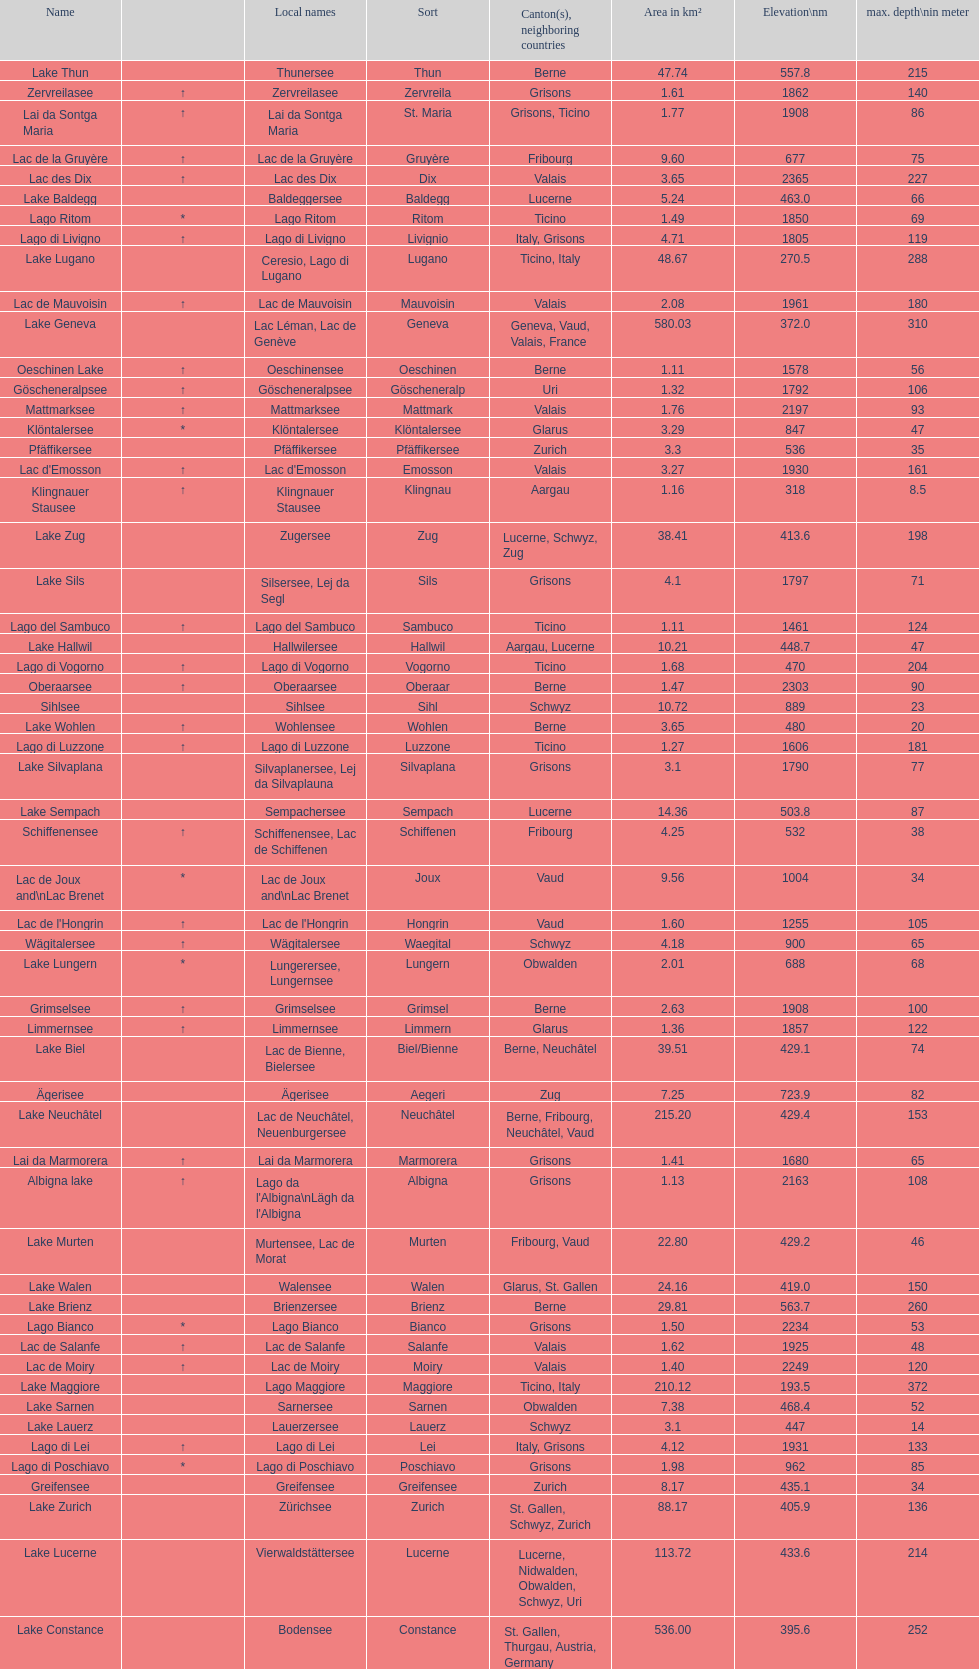Could you help me parse every detail presented in this table? {'header': ['Name', '', 'Local names', 'Sort', 'Canton(s), neighboring countries', 'Area in km²', 'Elevation\\nm', 'max. depth\\nin meter'], 'rows': [['Lake Thun', '', 'Thunersee', 'Thun', 'Berne', '47.74', '557.8', '215'], ['Zervreilasee', '↑', 'Zervreilasee', 'Zervreila', 'Grisons', '1.61', '1862', '140'], ['Lai da Sontga Maria', '↑', 'Lai da Sontga Maria', 'St. Maria', 'Grisons, Ticino', '1.77', '1908', '86'], ['Lac de la Gruyère', '↑', 'Lac de la Gruyère', 'Gruyère', 'Fribourg', '9.60', '677', '75'], ['Lac des Dix', '↑', 'Lac des Dix', 'Dix', 'Valais', '3.65', '2365', '227'], ['Lake Baldegg', '', 'Baldeggersee', 'Baldegg', 'Lucerne', '5.24', '463.0', '66'], ['Lago Ritom', '*', 'Lago Ritom', 'Ritom', 'Ticino', '1.49', '1850', '69'], ['Lago di Livigno', '↑', 'Lago di Livigno', 'Livignio', 'Italy, Grisons', '4.71', '1805', '119'], ['Lake Lugano', '', 'Ceresio, Lago di Lugano', 'Lugano', 'Ticino, Italy', '48.67', '270.5', '288'], ['Lac de Mauvoisin', '↑', 'Lac de Mauvoisin', 'Mauvoisin', 'Valais', '2.08', '1961', '180'], ['Lake Geneva', '', 'Lac Léman, Lac de Genève', 'Geneva', 'Geneva, Vaud, Valais, France', '580.03', '372.0', '310'], ['Oeschinen Lake', '↑', 'Oeschinensee', 'Oeschinen', 'Berne', '1.11', '1578', '56'], ['Göscheneralpsee', '↑', 'Göscheneralpsee', 'Göscheneralp', 'Uri', '1.32', '1792', '106'], ['Mattmarksee', '↑', 'Mattmarksee', 'Mattmark', 'Valais', '1.76', '2197', '93'], ['Klöntalersee', '*', 'Klöntalersee', 'Klöntalersee', 'Glarus', '3.29', '847', '47'], ['Pfäffikersee', '', 'Pfäffikersee', 'Pfäffikersee', 'Zurich', '3.3', '536', '35'], ["Lac d'Emosson", '↑', "Lac d'Emosson", 'Emosson', 'Valais', '3.27', '1930', '161'], ['Klingnauer Stausee', '↑', 'Klingnauer Stausee', 'Klingnau', 'Aargau', '1.16', '318', '8.5'], ['Lake Zug', '', 'Zugersee', 'Zug', 'Lucerne, Schwyz, Zug', '38.41', '413.6', '198'], ['Lake Sils', '', 'Silsersee, Lej da Segl', 'Sils', 'Grisons', '4.1', '1797', '71'], ['Lago del Sambuco', '↑', 'Lago del Sambuco', 'Sambuco', 'Ticino', '1.11', '1461', '124'], ['Lake Hallwil', '', 'Hallwilersee', 'Hallwil', 'Aargau, Lucerne', '10.21', '448.7', '47'], ['Lago di Vogorno', '↑', 'Lago di Vogorno', 'Vogorno', 'Ticino', '1.68', '470', '204'], ['Oberaarsee', '↑', 'Oberaarsee', 'Oberaar', 'Berne', '1.47', '2303', '90'], ['Sihlsee', '', 'Sihlsee', 'Sihl', 'Schwyz', '10.72', '889', '23'], ['Lake Wohlen', '↑', 'Wohlensee', 'Wohlen', 'Berne', '3.65', '480', '20'], ['Lago di Luzzone', '↑', 'Lago di Luzzone', 'Luzzone', 'Ticino', '1.27', '1606', '181'], ['Lake Silvaplana', '', 'Silvaplanersee, Lej da Silvaplauna', 'Silvaplana', 'Grisons', '3.1', '1790', '77'], ['Lake Sempach', '', 'Sempachersee', 'Sempach', 'Lucerne', '14.36', '503.8', '87'], ['Schiffenensee', '↑', 'Schiffenensee, Lac de Schiffenen', 'Schiffenen', 'Fribourg', '4.25', '532', '38'], ['Lac de Joux and\\nLac Brenet', '*', 'Lac de Joux and\\nLac Brenet', 'Joux', 'Vaud', '9.56', '1004', '34'], ["Lac de l'Hongrin", '↑', "Lac de l'Hongrin", 'Hongrin', 'Vaud', '1.60', '1255', '105'], ['Wägitalersee', '↑', 'Wägitalersee', 'Waegital', 'Schwyz', '4.18', '900', '65'], ['Lake Lungern', '*', 'Lungerersee, Lungernsee', 'Lungern', 'Obwalden', '2.01', '688', '68'], ['Grimselsee', '↑', 'Grimselsee', 'Grimsel', 'Berne', '2.63', '1908', '100'], ['Limmernsee', '↑', 'Limmernsee', 'Limmern', 'Glarus', '1.36', '1857', '122'], ['Lake Biel', '', 'Lac de Bienne, Bielersee', 'Biel/Bienne', 'Berne, Neuchâtel', '39.51', '429.1', '74'], ['Ägerisee', '', 'Ägerisee', 'Aegeri', 'Zug', '7.25', '723.9', '82'], ['Lake Neuchâtel', '', 'Lac de Neuchâtel, Neuenburgersee', 'Neuchâtel', 'Berne, Fribourg, Neuchâtel, Vaud', '215.20', '429.4', '153'], ['Lai da Marmorera', '↑', 'Lai da Marmorera', 'Marmorera', 'Grisons', '1.41', '1680', '65'], ['Albigna lake', '↑', "Lago da l'Albigna\\nLägh da l'Albigna", 'Albigna', 'Grisons', '1.13', '2163', '108'], ['Lake Murten', '', 'Murtensee, Lac de Morat', 'Murten', 'Fribourg, Vaud', '22.80', '429.2', '46'], ['Lake Walen', '', 'Walensee', 'Walen', 'Glarus, St. Gallen', '24.16', '419.0', '150'], ['Lake Brienz', '', 'Brienzersee', 'Brienz', 'Berne', '29.81', '563.7', '260'], ['Lago Bianco', '*', 'Lago Bianco', 'Bianco', 'Grisons', '1.50', '2234', '53'], ['Lac de Salanfe', '↑', 'Lac de Salanfe', 'Salanfe', 'Valais', '1.62', '1925', '48'], ['Lac de Moiry', '↑', 'Lac de Moiry', 'Moiry', 'Valais', '1.40', '2249', '120'], ['Lake Maggiore', '', 'Lago Maggiore', 'Maggiore', 'Ticino, Italy', '210.12', '193.5', '372'], ['Lake Sarnen', '', 'Sarnersee', 'Sarnen', 'Obwalden', '7.38', '468.4', '52'], ['Lake Lauerz', '', 'Lauerzersee', 'Lauerz', 'Schwyz', '3.1', '447', '14'], ['Lago di Lei', '↑', 'Lago di Lei', 'Lei', 'Italy, Grisons', '4.12', '1931', '133'], ['Lago di Poschiavo', '*', 'Lago di Poschiavo', 'Poschiavo', 'Grisons', '1.98', '962', '85'], ['Greifensee', '', 'Greifensee', 'Greifensee', 'Zurich', '8.17', '435.1', '34'], ['Lake Zurich', '', 'Zürichsee', 'Zurich', 'St. Gallen, Schwyz, Zurich', '88.17', '405.9', '136'], ['Lake Lucerne', '', 'Vierwaldstättersee', 'Lucerne', 'Lucerne, Nidwalden, Obwalden, Schwyz, Uri', '113.72', '433.6', '214'], ['Lake Constance', '', 'Bodensee', 'Constance', 'St. Gallen, Thurgau, Austria, Germany', '536.00', '395.6', '252']]} Which lake has the greatest elevation? Lac des Dix. 